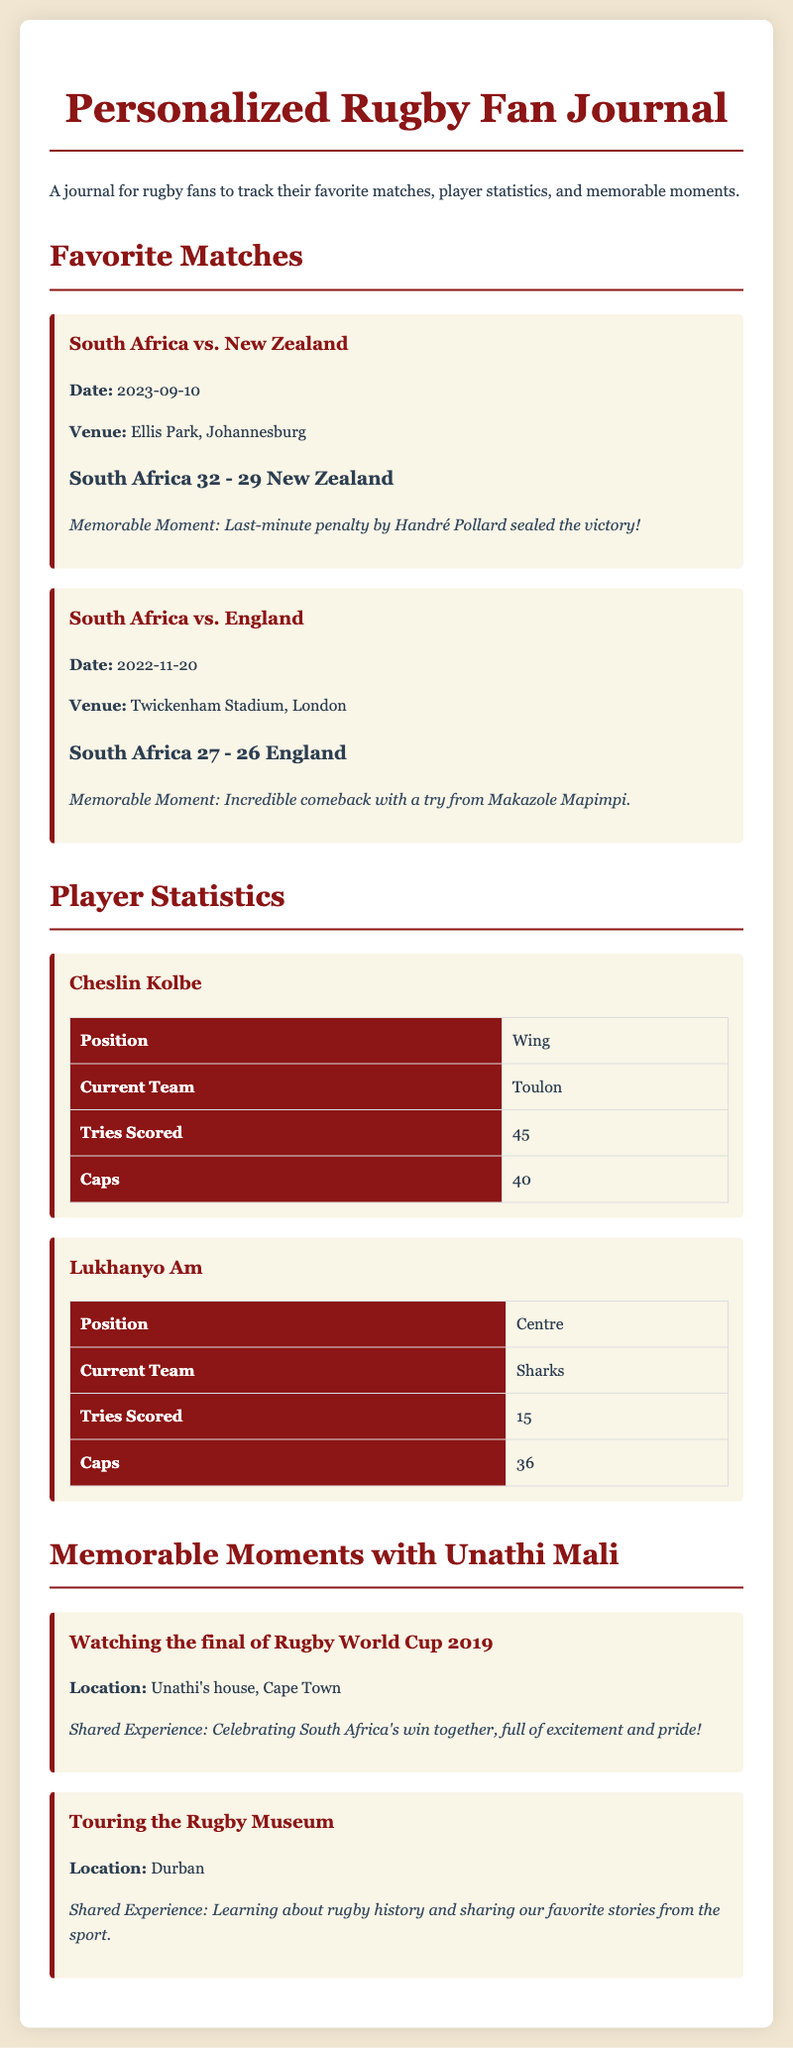What is the date of the match between South Africa and New Zealand? The date of the match is listed under the match details.
Answer: 2023-09-10 Who scored the last-minute penalty in the South Africa vs. New Zealand match? The name of the player who scored the penalty is mentioned in the memorable moment of the match.
Answer: Handré Pollard What was the score of the match between South Africa and England? The score is highlighted in the match details.
Answer: South Africa 27 - 26 England How many tries has Cheslin Kolbe scored? The number of tries scored by Cheslin Kolbe is given in his player statistics.
Answer: 45 What was a shared experience with Unathi Mali while watching the Rugby World Cup 2019 final? This is explained in the memorable moments section detailing experiences with Unathi Mali.
Answer: Celebrating South Africa's win together Which player has the fewest caps listed? This requires comparing the caps of both players mentioned in the statistics section.
Answer: Lukhanyo Am What location is associated with touring the Rugby Museum? The location is specified in the memorable moments section.
Answer: Durban How many caps does Lukhanyo Am have? The number of caps for Lukhanyo Am is stated in the player statistics.
Answer: 36 What is the current team of Cheslin Kolbe? The current team of Cheslin Kolbe can be found in his player statistics.
Answer: Toulon 